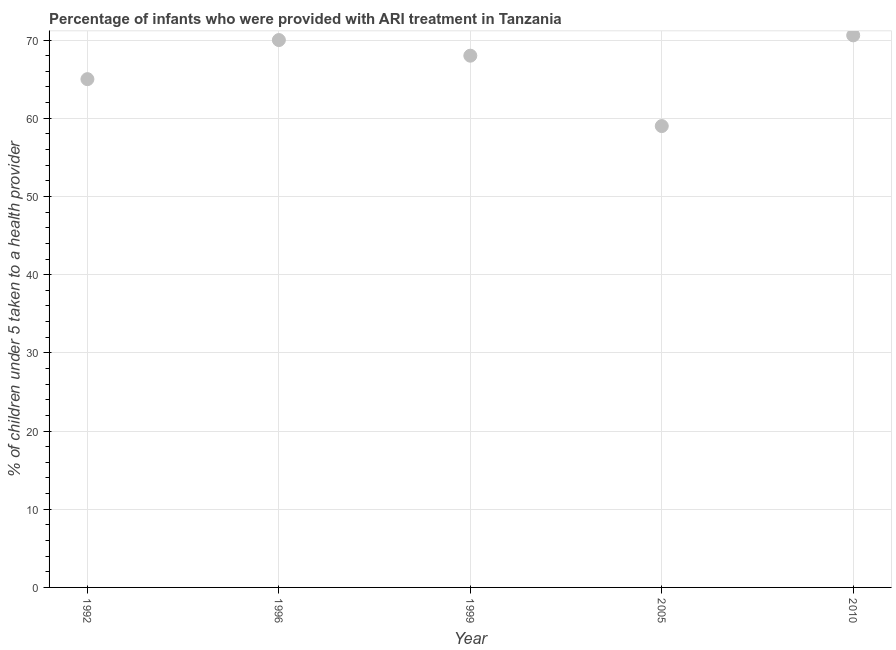What is the percentage of children who were provided with ari treatment in 2010?
Give a very brief answer. 70.6. Across all years, what is the maximum percentage of children who were provided with ari treatment?
Offer a terse response. 70.6. Across all years, what is the minimum percentage of children who were provided with ari treatment?
Your answer should be very brief. 59. In which year was the percentage of children who were provided with ari treatment minimum?
Your answer should be compact. 2005. What is the sum of the percentage of children who were provided with ari treatment?
Ensure brevity in your answer.  332.6. What is the difference between the percentage of children who were provided with ari treatment in 1996 and 1999?
Offer a terse response. 2. What is the average percentage of children who were provided with ari treatment per year?
Keep it short and to the point. 66.52. In how many years, is the percentage of children who were provided with ari treatment greater than 8 %?
Ensure brevity in your answer.  5. What is the ratio of the percentage of children who were provided with ari treatment in 1996 to that in 1999?
Provide a succinct answer. 1.03. Is the percentage of children who were provided with ari treatment in 1992 less than that in 1999?
Offer a terse response. Yes. Is the difference between the percentage of children who were provided with ari treatment in 1992 and 1999 greater than the difference between any two years?
Give a very brief answer. No. What is the difference between the highest and the second highest percentage of children who were provided with ari treatment?
Offer a terse response. 0.6. What is the difference between the highest and the lowest percentage of children who were provided with ari treatment?
Ensure brevity in your answer.  11.6. How many dotlines are there?
Make the answer very short. 1. How many years are there in the graph?
Provide a short and direct response. 5. What is the difference between two consecutive major ticks on the Y-axis?
Offer a very short reply. 10. What is the title of the graph?
Your response must be concise. Percentage of infants who were provided with ARI treatment in Tanzania. What is the label or title of the Y-axis?
Your answer should be compact. % of children under 5 taken to a health provider. What is the % of children under 5 taken to a health provider in 1992?
Keep it short and to the point. 65. What is the % of children under 5 taken to a health provider in 1996?
Provide a short and direct response. 70. What is the % of children under 5 taken to a health provider in 1999?
Keep it short and to the point. 68. What is the % of children under 5 taken to a health provider in 2010?
Give a very brief answer. 70.6. What is the difference between the % of children under 5 taken to a health provider in 1992 and 1999?
Provide a succinct answer. -3. What is the difference between the % of children under 5 taken to a health provider in 1992 and 2005?
Provide a succinct answer. 6. What is the difference between the % of children under 5 taken to a health provider in 1996 and 2010?
Offer a terse response. -0.6. What is the difference between the % of children under 5 taken to a health provider in 1999 and 2005?
Your answer should be very brief. 9. What is the difference between the % of children under 5 taken to a health provider in 2005 and 2010?
Your answer should be compact. -11.6. What is the ratio of the % of children under 5 taken to a health provider in 1992 to that in 1996?
Offer a very short reply. 0.93. What is the ratio of the % of children under 5 taken to a health provider in 1992 to that in 1999?
Provide a short and direct response. 0.96. What is the ratio of the % of children under 5 taken to a health provider in 1992 to that in 2005?
Provide a succinct answer. 1.1. What is the ratio of the % of children under 5 taken to a health provider in 1992 to that in 2010?
Provide a short and direct response. 0.92. What is the ratio of the % of children under 5 taken to a health provider in 1996 to that in 1999?
Your answer should be compact. 1.03. What is the ratio of the % of children under 5 taken to a health provider in 1996 to that in 2005?
Your answer should be very brief. 1.19. What is the ratio of the % of children under 5 taken to a health provider in 1996 to that in 2010?
Offer a very short reply. 0.99. What is the ratio of the % of children under 5 taken to a health provider in 1999 to that in 2005?
Ensure brevity in your answer.  1.15. What is the ratio of the % of children under 5 taken to a health provider in 2005 to that in 2010?
Provide a short and direct response. 0.84. 